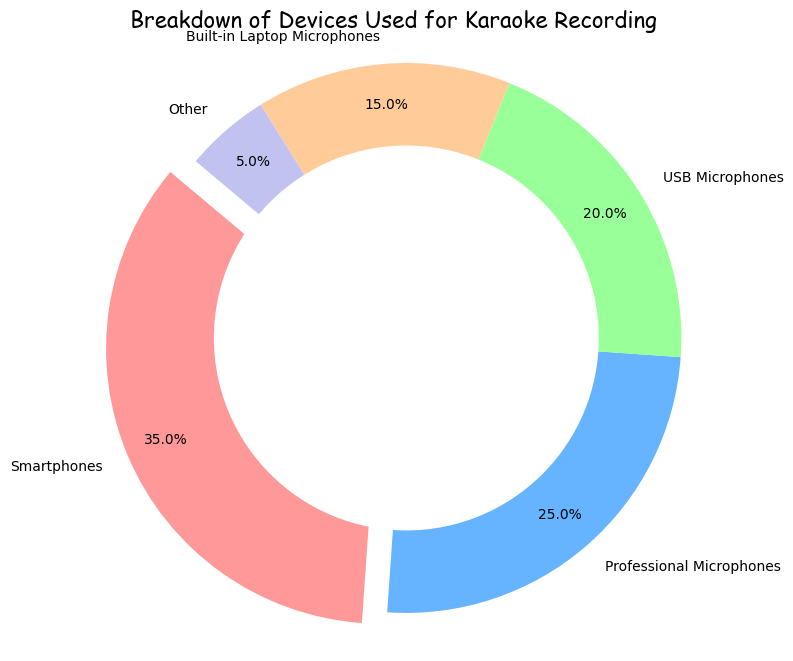Which device has the highest percentage? The pie chart shows that smartphones have the largest segment and a percentage of 35%, making them the device with the highest usage.
Answer: Smartphones How much greater is the percentage of smartphones compared to built-in laptop microphones? The percentage of smartphones is 35%, and the percentage of built-in laptop microphones is 15%. The difference between them is 35% - 15% = 20%.
Answer: 20% What is the combined percentage of usage for professional microphones and USB microphones? The percentages for professional microphones and USB microphones are 25% and 20%, respectively. Adding these gives 25% + 20% = 45%.
Answer: 45% Which device has the smallest percentage? The pie chart shows that the "Other" category has the smallest segment with a percentage of 5%.
Answer: Other Compare the usage percentages of professional microphones and USB microphones. Which one is higher and by how much? Professional microphones have a percentage of 25%, while USB microphones have 20%. The difference between them is 25% - 20% = 5%, making professional microphones higher by 5%.
Answer: Professional microphones, 5% How are the devices represented in terms of color? The pie chart uses different colors for each device as follows: smartphones (red), professional microphones (blue), USB microphones (green), built-in laptop microphones (orange), and other (purple).
Answer: Smartphones (red), Professional Microphones (blue), USB Microphones (green), Built-in Laptop Microphones (orange), Other (purple) What is the total percentage of all devices used for karaoke recording? Since the chart represents all device categories, the total percentage is the sum of all segments: 35% (Smartphones) + 25% (Professional Microphones) + 20% (USB Microphones) + 15% (Built-in Laptop Microphones) + 5% (Other) = 100%.
Answer: 100% Which two devices together contribute to more than half of the total percentage? The two largest segments are smartphones (35%) and professional microphones (25%). Together, they make 35% + 25% = 60%, which is more than half of the total percentage.
Answer: Smartphones and Professional Microphones 